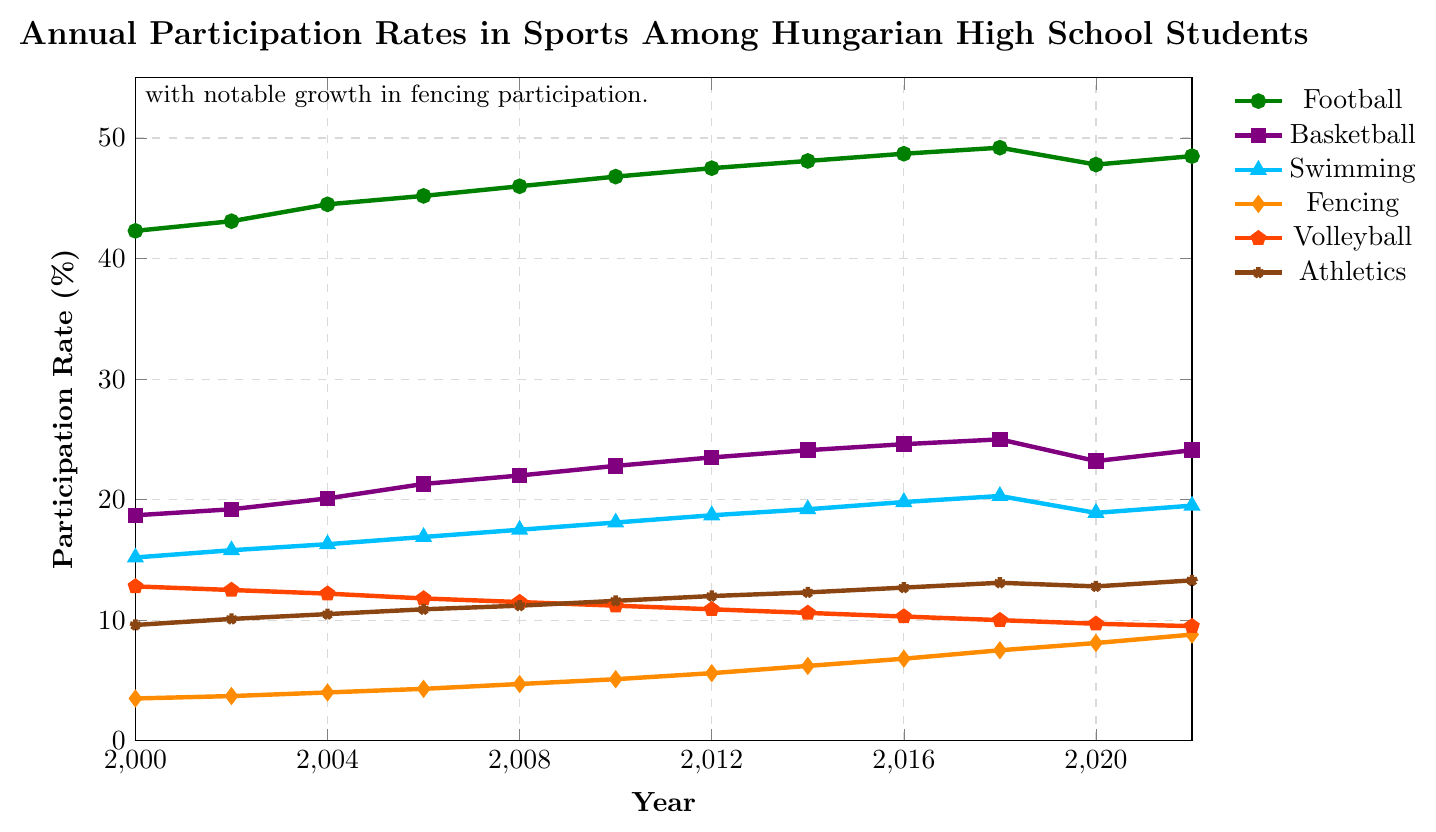Which sport had the highest participation rate in 2008? To determine the sport with the highest participation rate in 2008, look at the lines for that year and identify which one reaches the highest value on the y-axis.
Answer: Football What was the percentage increase in participation for fencing from 2000 to 2022? Find the participation rate for fencing in 2000 and 2022, then calculate the percentage increase using the formula: [(8.8 - 3.5) / 3.5] * 100.
Answer: 151.43% Which years saw a decline in participation for volleyball? Look at the volleyball line and identify the years where the participation rate decreased from the previous year.
Answer: 2000-2002, 2002-2004, 2004-2006, 2006-2008, 2008-2010, 2010-2012, 2012-2014, 2014-2016, 2016-2018, 2018-2020, 2020-2022 In which year did basketball participation just surpass 20%? Locate the point on the basketball line where the participation rate first reaches just above 20%.
Answer: 2004 Which sport had the smallest change in participation rate over the entire period? Compare the difference in participation rates from 2000 to 2022 for each sport and identify the smallest difference.
Answer: Volleyball How did the participation in athletics change from 2008 to 2012? Look at the athletics line and find the participation rate in 2008 and 2012. Calculate the difference between these years.
Answer: Increased by 0.8% If the rates in 2022 continued to grow at the same rate per year as from 2018 to 2022, what would be the expected participation rate for swimming in 2024? Calculate the growth rate per year from 2018 to 2022 for swimming. Apply this rate to project the value for 2024. Growth from 2018 to 2022 is (19.5 - 20.3)/4 per year, so the expected rate in 2024 is 19.5 - 2*(0.2), which is 19.1.
Answer: 19.1% Which sport had a higher participation rate overall, football or basketball, and by how much in 2020? Compare the participation rates of football and basketball in 2020 and find the difference between them.
Answer: Football, by 24.6% What's the average change in participation rate for fencing every two years from 2000 to 2022? Calculate the change in participation rate for fencing every two years and then find the average of these changes.
Answer: 0.44% Which sport experienced the most consistent increase in participation rates over the years? Analyze the trends by looking at how steadily each line rises on the graph.
Answer: Fencing 